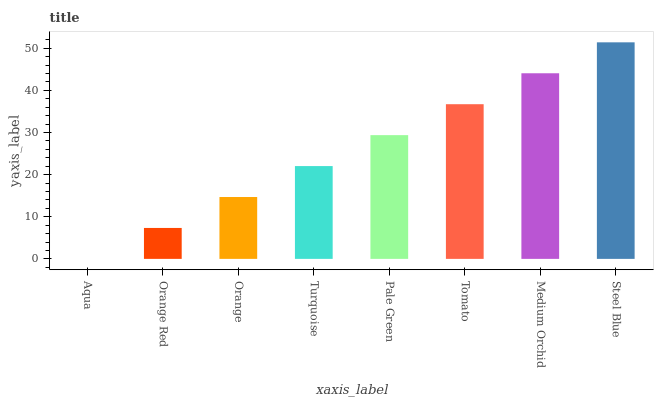Is Aqua the minimum?
Answer yes or no. Yes. Is Steel Blue the maximum?
Answer yes or no. Yes. Is Orange Red the minimum?
Answer yes or no. No. Is Orange Red the maximum?
Answer yes or no. No. Is Orange Red greater than Aqua?
Answer yes or no. Yes. Is Aqua less than Orange Red?
Answer yes or no. Yes. Is Aqua greater than Orange Red?
Answer yes or no. No. Is Orange Red less than Aqua?
Answer yes or no. No. Is Pale Green the high median?
Answer yes or no. Yes. Is Turquoise the low median?
Answer yes or no. Yes. Is Orange Red the high median?
Answer yes or no. No. Is Orange Red the low median?
Answer yes or no. No. 